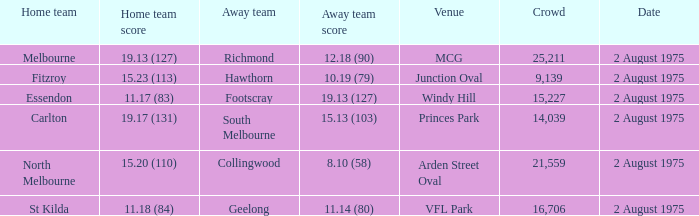What did the away team score when playing North Melbourne? 8.10 (58). 